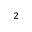Convert formula to latex. <formula><loc_0><loc_0><loc_500><loc_500>^ { 2 }</formula> 